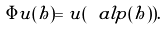<formula> <loc_0><loc_0><loc_500><loc_500>\Phi u ( h ) = u ( \ a l p ( h ) ) .</formula> 